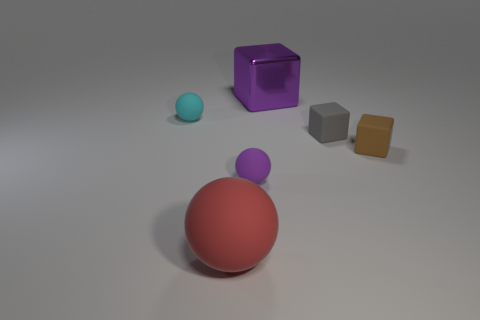There is another large object that is the same shape as the purple rubber object; what color is it?
Offer a terse response. Red. Are there any other things that are the same shape as the tiny brown thing?
Keep it short and to the point. Yes. There is a big rubber object; is its shape the same as the purple object that is left of the purple shiny block?
Offer a very short reply. Yes. What is the red sphere made of?
Keep it short and to the point. Rubber. There is a brown matte object that is the same shape as the gray rubber object; what size is it?
Make the answer very short. Small. What number of other things are there of the same material as the purple ball
Give a very brief answer. 4. Do the red ball and the big object that is behind the big rubber thing have the same material?
Make the answer very short. No. Are there fewer red balls to the right of the large purple metal thing than large purple shiny things to the left of the large red matte sphere?
Give a very brief answer. No. There is a big object in front of the brown cube; what is its color?
Keep it short and to the point. Red. What number of other things are the same color as the metallic cube?
Your response must be concise. 1. 